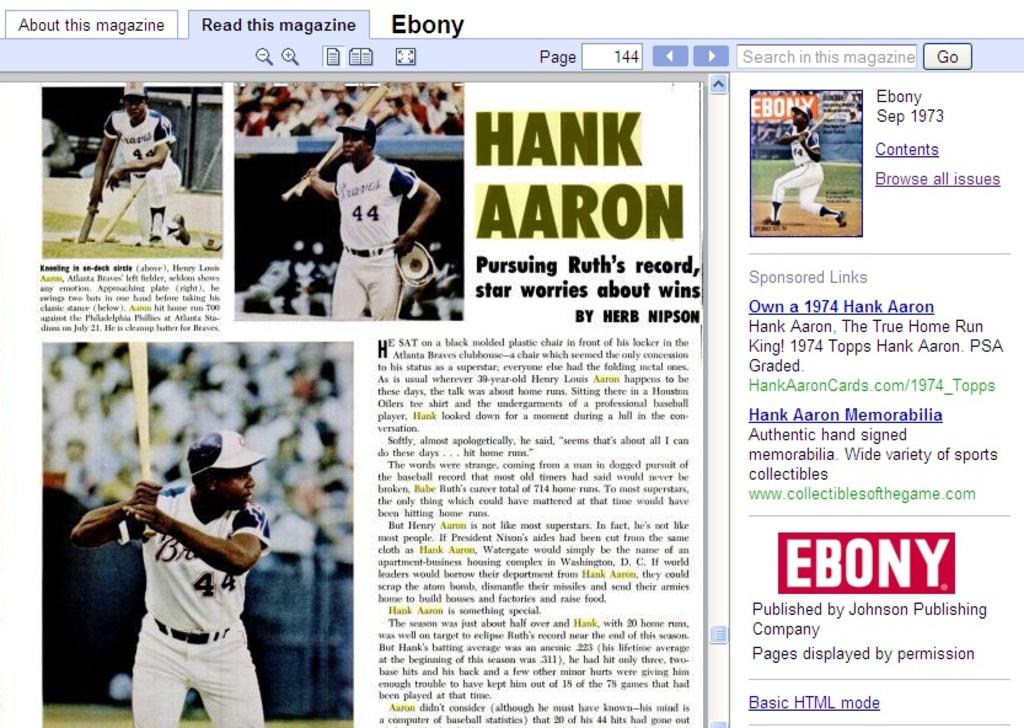Who did hank aaron play for?
Your answer should be compact. Braves. Is this an article from ebony magazine?
Offer a very short reply. Yes. 